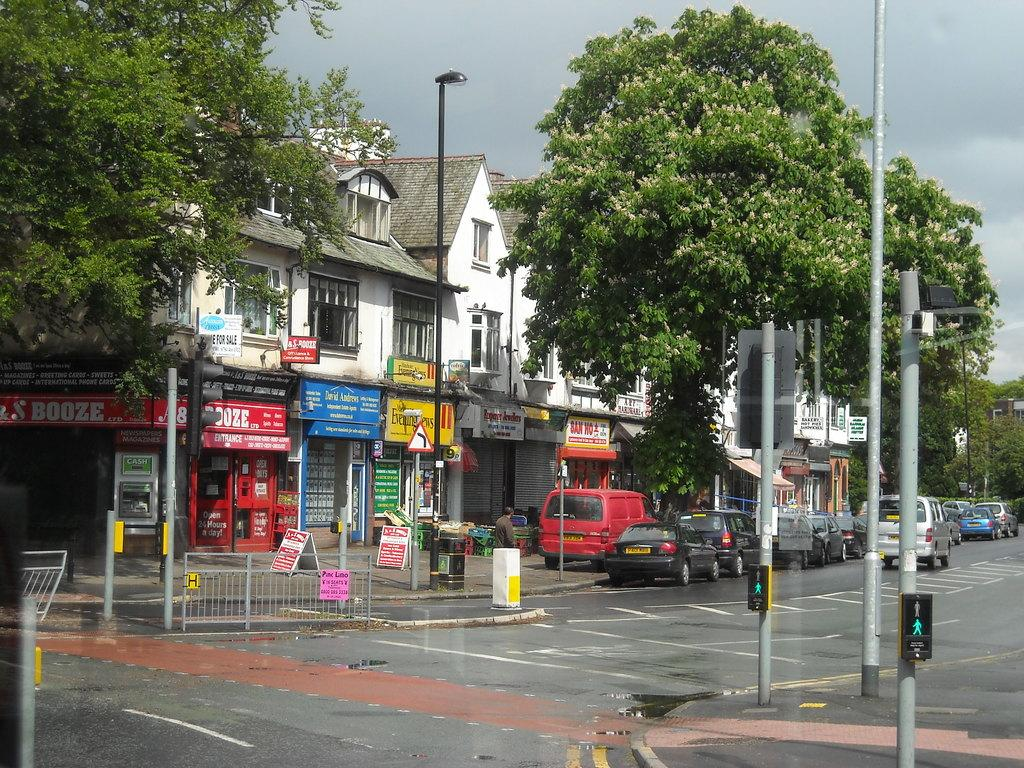<image>
Give a short and clear explanation of the subsequent image. A booze store is next to a store owned by David Andrews. 